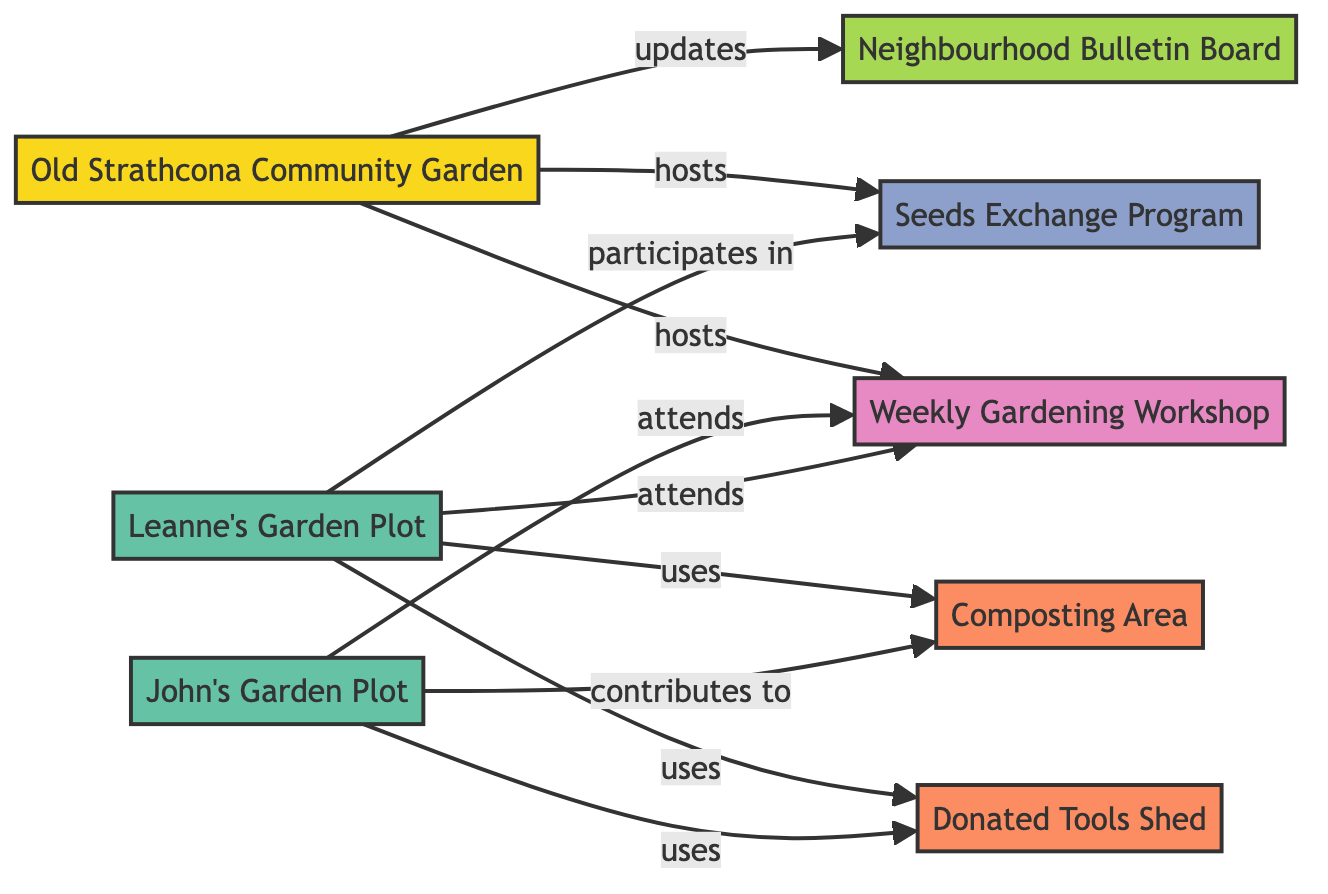What is the label of node 1? Node 1 in the diagram is labeled as "Old Strathcona Community Garden."
Answer: Old Strathcona Community Garden How many individual plots are shown in the diagram? The diagram displays two individual plots, labeled as "Leanne's Garden Plot" and "John's Garden Plot."
Answer: 2 What type of resource does "Leanne's Garden Plot" use? "Leanne's Garden Plot" is connected to the "Donated Tools Shed," indicating it uses this resource.
Answer: Donated Tools Shed What relationship does "John's Garden Plot" have with the Composting Area? The relationship depicted is that "John's Garden Plot" contributes to the Composting Area, indicating active participation in its maintenance.
Answer: contributes to Which node is hosted by the Old Strathcona Community Garden? The diagram indicates that the "Seeds Exchange Program" and "Weekly Gardening Workshop" are hosted by the Old Strathcona Community Garden. During review, the hosting is specific to these two initiatives.
Answer: Seeds Exchange Program, Weekly Gardening Workshop Who participates in the Seeds Exchange Program? The participants are identified as both "Leanne's Garden Plot" and "Old Strathcona Community Garden." Specifically, "Leanne's Garden Plot" is explicitly mentioned to participate in this program.
Answer: Leanne's Garden Plot What event do both garden plots attend? Both "Leanne's Garden Plot" and "John's Garden Plot" attend the "Weekly Gardening Workshop," which shows a collaborative effort in learning and gardening.
Answer: Weekly Gardening Workshop How many resources are represented in the diagram? There are two resources shown: "Donated Tools Shed" and "Composting Area," contributing to the gardening efforts in the community.
Answer: 2 What kind of communication channel is used in the neighborhood? The "Neighbourhood Bulletin Board" serves as the communication channel, used by the Old Strathcona Community Garden to provide updates.
Answer: Neighbourhood Bulletin Board 